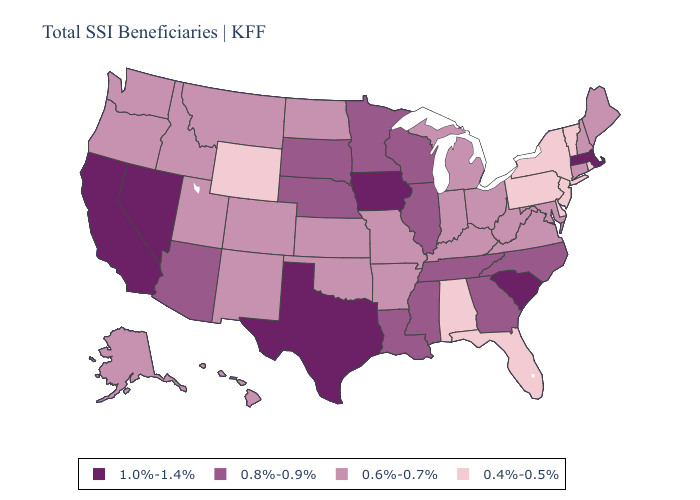Does Montana have the lowest value in the USA?
Short answer required. No. What is the value of Arkansas?
Concise answer only. 0.6%-0.7%. Among the states that border Mississippi , which have the highest value?
Concise answer only. Louisiana, Tennessee. Name the states that have a value in the range 1.0%-1.4%?
Answer briefly. California, Iowa, Massachusetts, Nevada, South Carolina, Texas. Name the states that have a value in the range 0.8%-0.9%?
Answer briefly. Arizona, Georgia, Illinois, Louisiana, Minnesota, Mississippi, Nebraska, North Carolina, South Dakota, Tennessee, Wisconsin. Name the states that have a value in the range 0.6%-0.7%?
Be succinct. Alaska, Arkansas, Colorado, Connecticut, Hawaii, Idaho, Indiana, Kansas, Kentucky, Maine, Maryland, Michigan, Missouri, Montana, New Hampshire, New Mexico, North Dakota, Ohio, Oklahoma, Oregon, Utah, Virginia, Washington, West Virginia. Among the states that border Kentucky , which have the lowest value?
Concise answer only. Indiana, Missouri, Ohio, Virginia, West Virginia. What is the value of Maine?
Give a very brief answer. 0.6%-0.7%. Is the legend a continuous bar?
Be succinct. No. What is the lowest value in states that border Utah?
Quick response, please. 0.4%-0.5%. What is the value of Georgia?
Answer briefly. 0.8%-0.9%. Name the states that have a value in the range 1.0%-1.4%?
Write a very short answer. California, Iowa, Massachusetts, Nevada, South Carolina, Texas. Name the states that have a value in the range 1.0%-1.4%?
Answer briefly. California, Iowa, Massachusetts, Nevada, South Carolina, Texas. Name the states that have a value in the range 1.0%-1.4%?
Give a very brief answer. California, Iowa, Massachusetts, Nevada, South Carolina, Texas. 